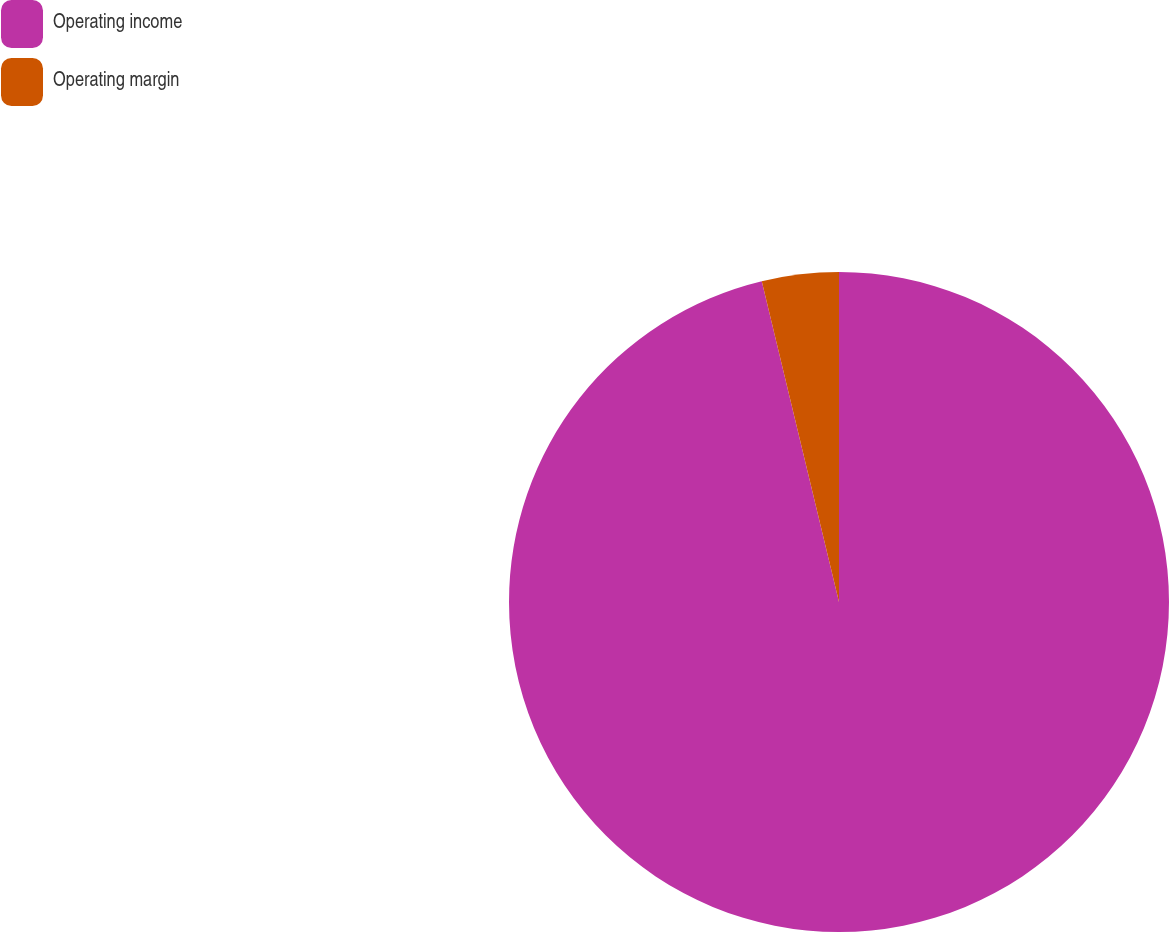Convert chart to OTSL. <chart><loc_0><loc_0><loc_500><loc_500><pie_chart><fcel>Operating income<fcel>Operating margin<nl><fcel>96.24%<fcel>3.76%<nl></chart> 